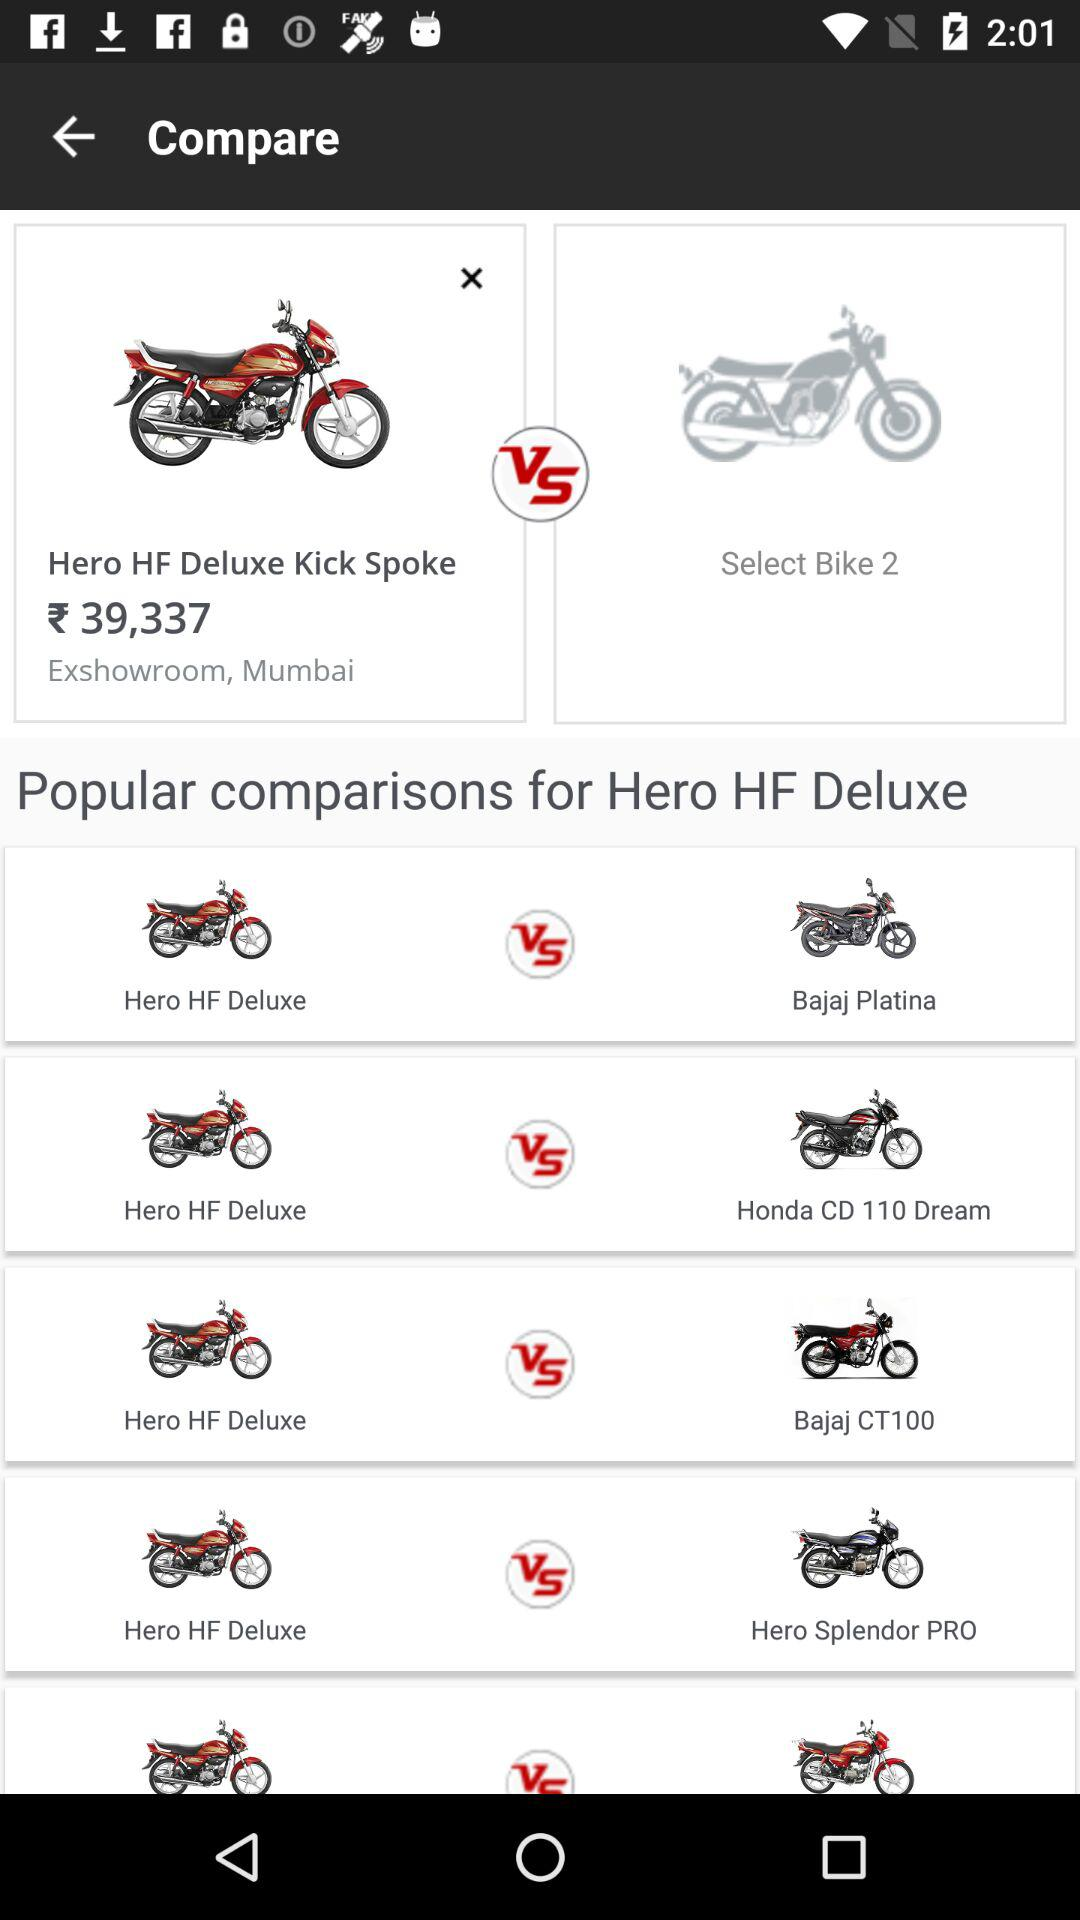What is the price of the Hero HF Deluxe Kick Spoke? The price of the Hero HF Deluxe Kick Spoke is ₹39,337. 